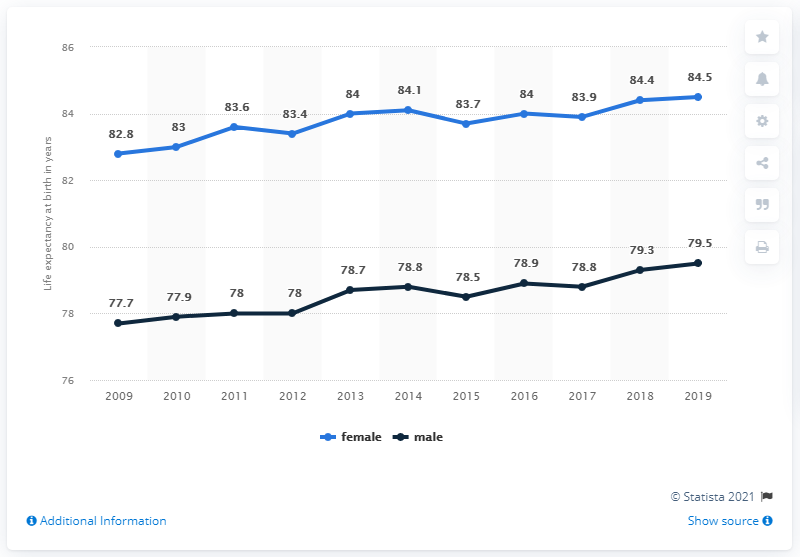Outline some significant characteristics in this image. In 2015, the average life expectancy was 81.1 years. The gender with the highest life expectancy is female. 